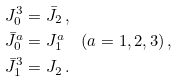Convert formula to latex. <formula><loc_0><loc_0><loc_500><loc_500>J _ { 0 } ^ { 3 } & = \bar { J } _ { 2 } \, , \\ \bar { J } _ { 0 } ^ { a } & = J _ { 1 } ^ { a } \quad ( a = 1 , 2 , 3 ) \, , \\ \bar { J } _ { 1 } ^ { 3 } & = J _ { 2 } \, .</formula> 